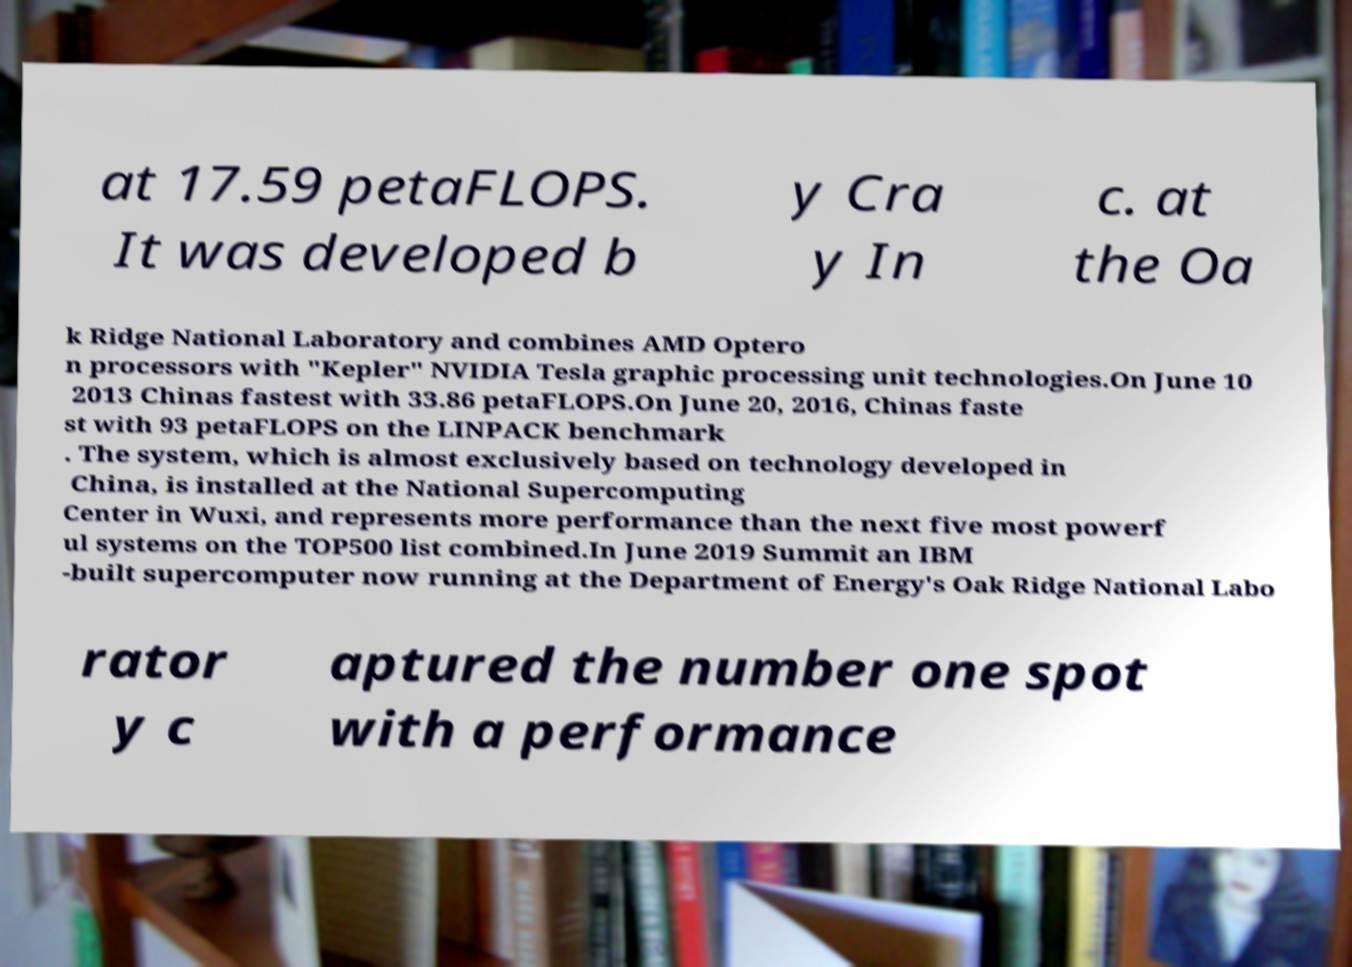There's text embedded in this image that I need extracted. Can you transcribe it verbatim? at 17.59 petaFLOPS. It was developed b y Cra y In c. at the Oa k Ridge National Laboratory and combines AMD Optero n processors with "Kepler" NVIDIA Tesla graphic processing unit technologies.On June 10 2013 Chinas fastest with 33.86 petaFLOPS.On June 20, 2016, Chinas faste st with 93 petaFLOPS on the LINPACK benchmark . The system, which is almost exclusively based on technology developed in China, is installed at the National Supercomputing Center in Wuxi, and represents more performance than the next five most powerf ul systems on the TOP500 list combined.In June 2019 Summit an IBM -built supercomputer now running at the Department of Energy's Oak Ridge National Labo rator y c aptured the number one spot with a performance 